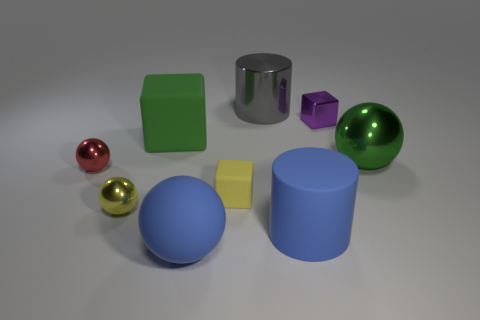There is a thing that is the same color as the big metal sphere; what is it made of?
Ensure brevity in your answer.  Rubber. There is a big green metallic object; are there any large spheres in front of it?
Give a very brief answer. Yes. Are there any yellow matte things that have the same shape as the purple thing?
Offer a terse response. Yes. There is a tiny thing that is to the left of the tiny yellow metallic ball; is its shape the same as the large blue matte thing that is to the left of the gray shiny object?
Make the answer very short. Yes. Are there any yellow blocks of the same size as the purple thing?
Provide a succinct answer. Yes. Are there the same number of big rubber cylinders that are to the left of the blue ball and large blue rubber spheres that are behind the matte cylinder?
Offer a terse response. Yes. Is the material of the green object on the left side of the large gray cylinder the same as the large ball that is left of the yellow rubber thing?
Offer a very short reply. Yes. What is the material of the gray cylinder?
Make the answer very short. Metal. What number of other objects are there of the same color as the metallic cube?
Make the answer very short. 0. Is the big metal sphere the same color as the big cube?
Make the answer very short. Yes. 